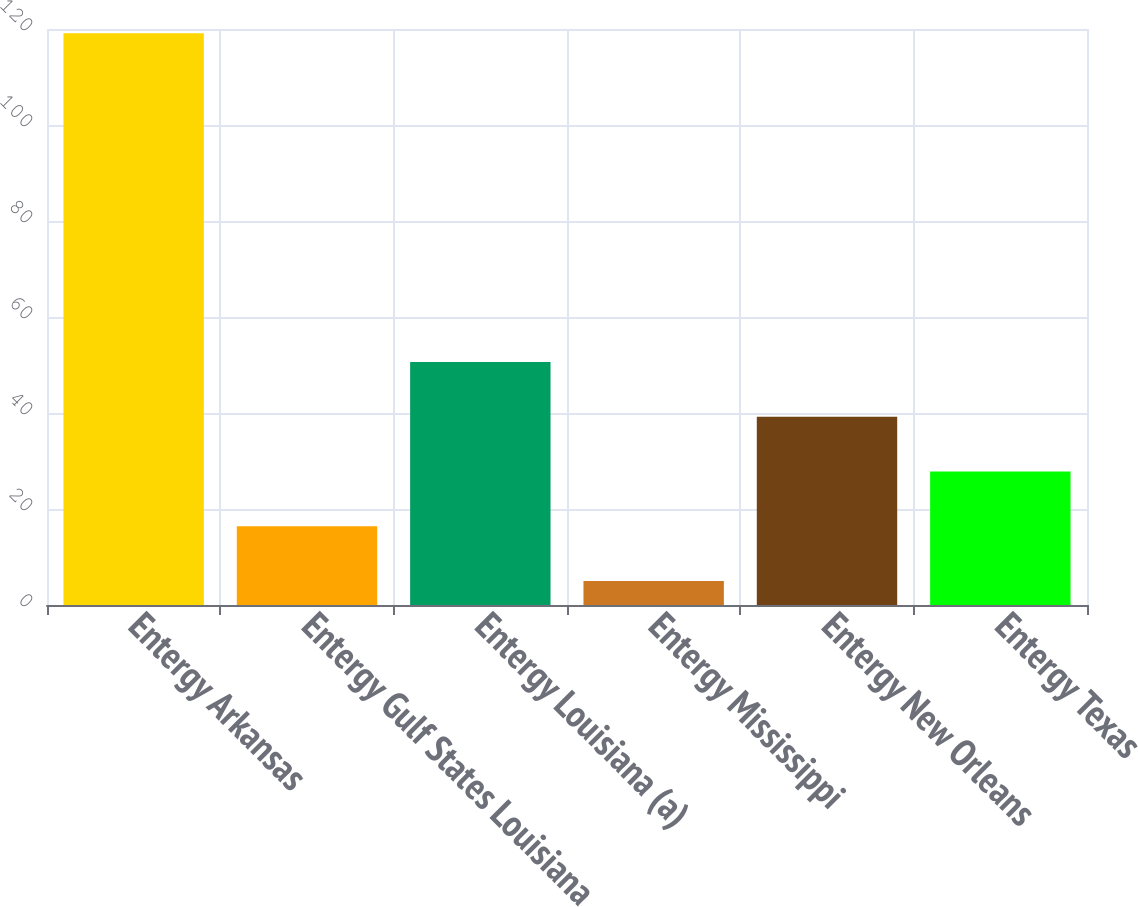Convert chart to OTSL. <chart><loc_0><loc_0><loc_500><loc_500><bar_chart><fcel>Entergy Arkansas<fcel>Entergy Gulf States Louisiana<fcel>Entergy Louisiana (a)<fcel>Entergy Mississippi<fcel>Entergy New Orleans<fcel>Entergy Texas<nl><fcel>119.1<fcel>16.41<fcel>50.64<fcel>5<fcel>39.23<fcel>27.82<nl></chart> 